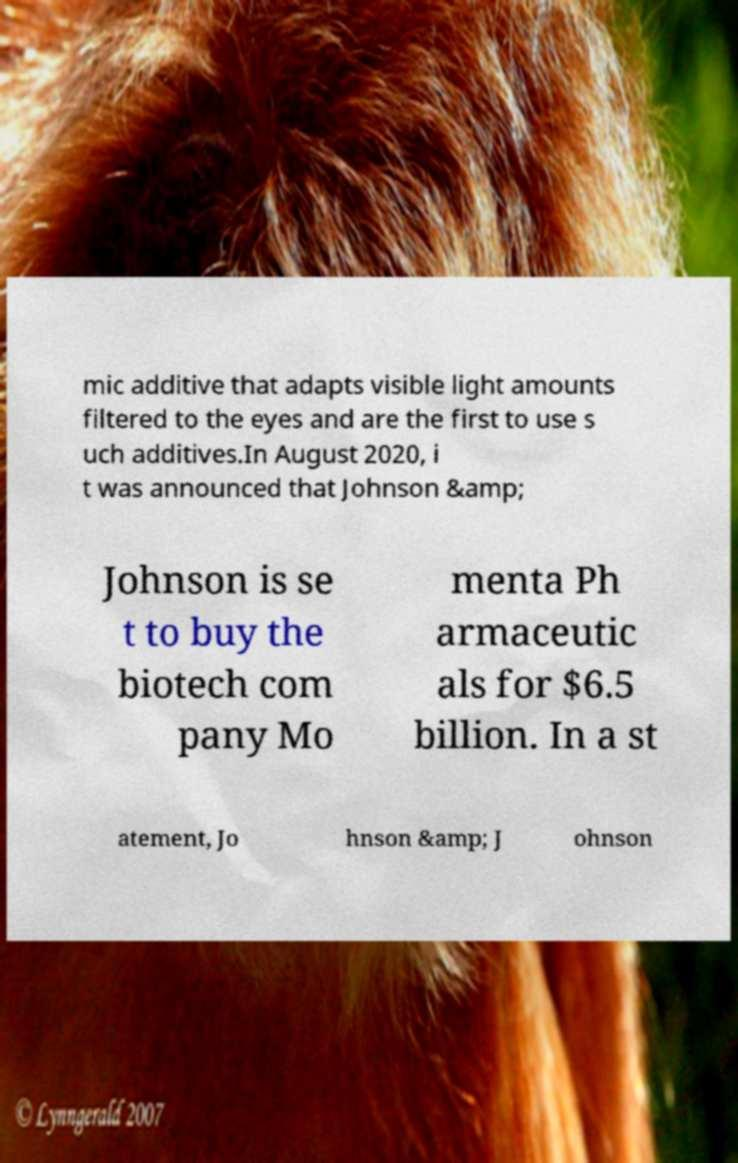Could you assist in decoding the text presented in this image and type it out clearly? mic additive that adapts visible light amounts filtered to the eyes and are the first to use s uch additives.In August 2020, i t was announced that Johnson &amp; Johnson is se t to buy the biotech com pany Mo menta Ph armaceutic als for $6.5 billion. In a st atement, Jo hnson &amp; J ohnson 